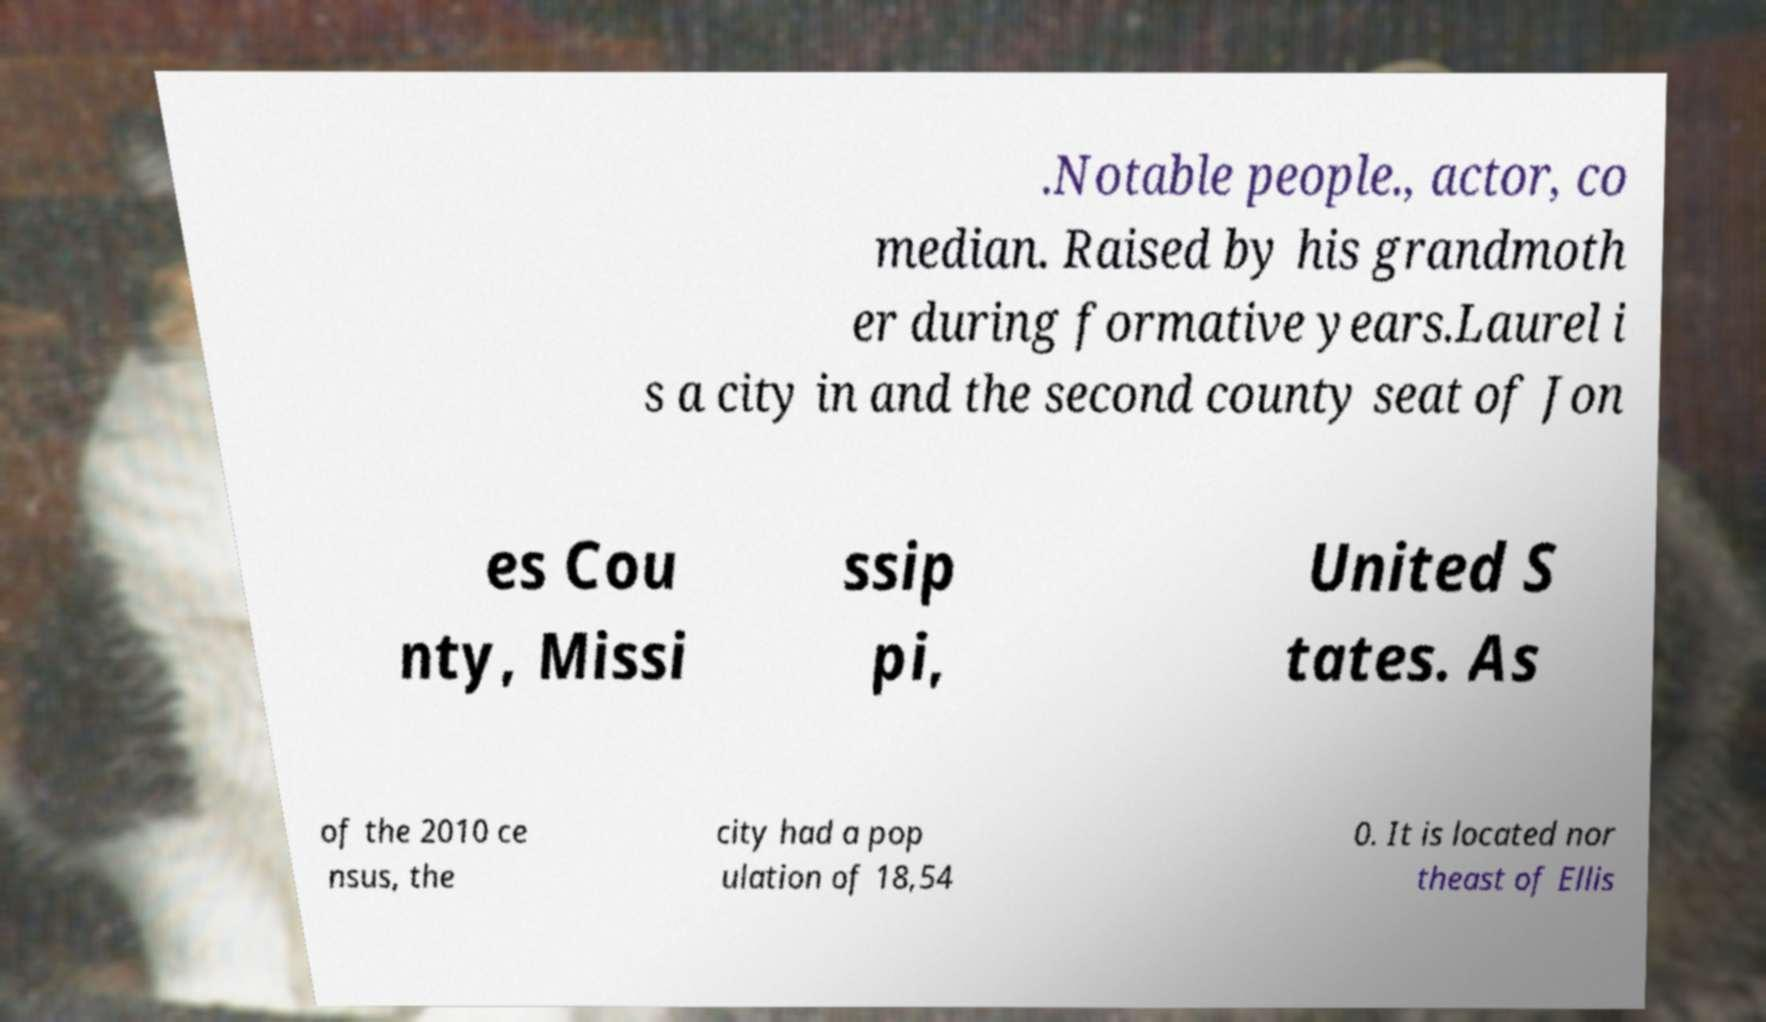There's text embedded in this image that I need extracted. Can you transcribe it verbatim? .Notable people., actor, co median. Raised by his grandmoth er during formative years.Laurel i s a city in and the second county seat of Jon es Cou nty, Missi ssip pi, United S tates. As of the 2010 ce nsus, the city had a pop ulation of 18,54 0. It is located nor theast of Ellis 